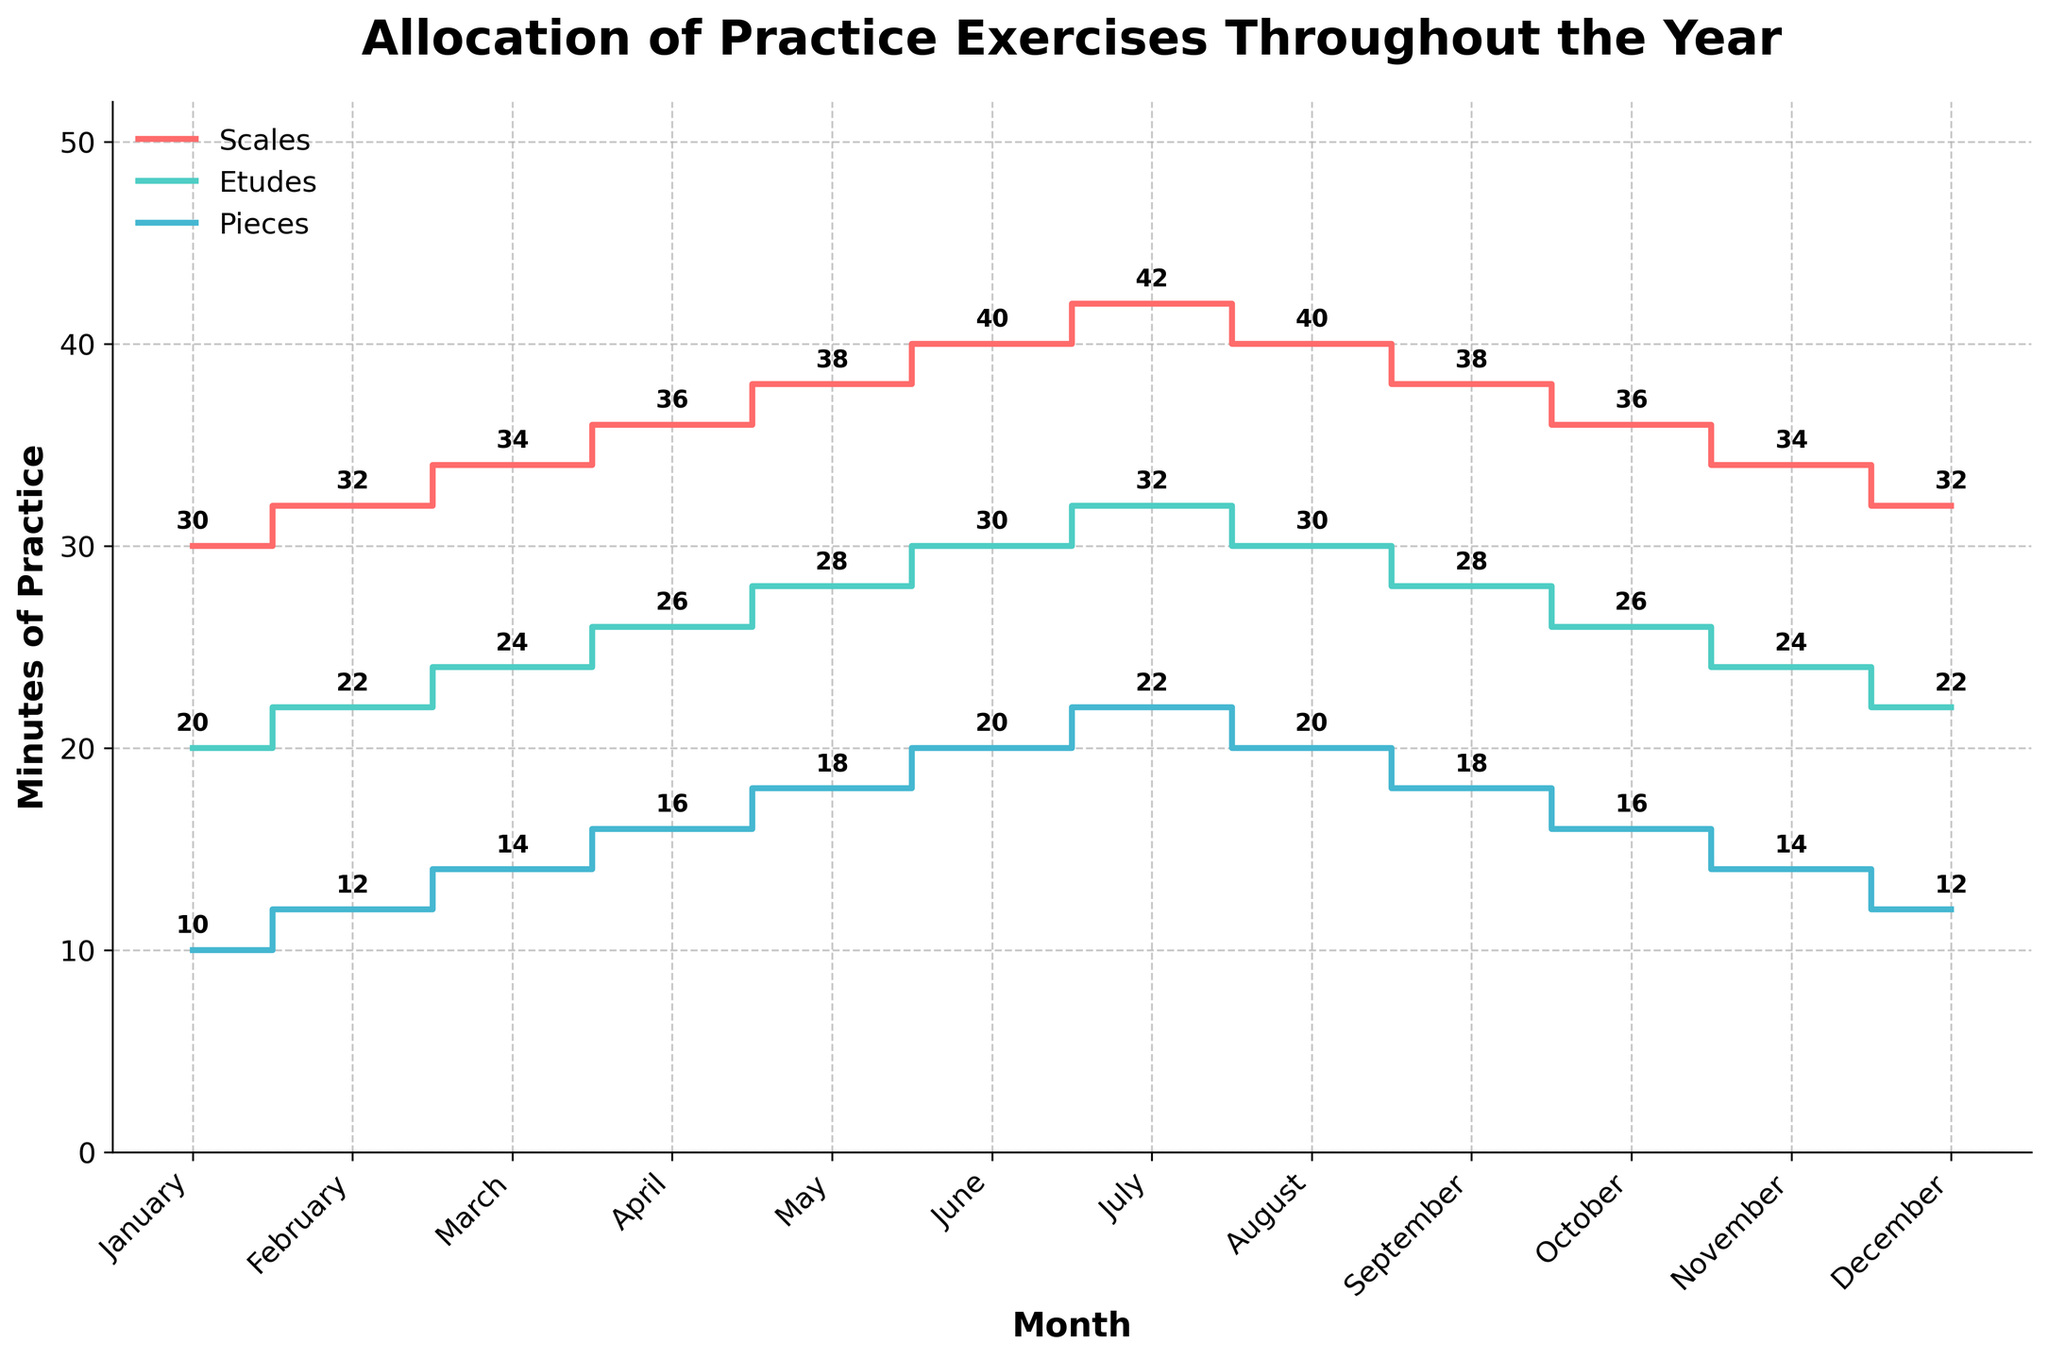What's the title of the plot? The title of the plot is mentioned at the top, in larger and bold font, which helps identify the main topic of the visualization.
Answer: Allocation of Practice Exercises Throughout the Year How many minutes were allocated to scales practice in June? Look at the point corresponding to June on the Scales stair plot line and read the annotation.
Answer: 40 In which month were the minutes allocated to etudes the highest? Identify the highest point of the Etudes stair plot line and see which month it corresponds to from the x-axis labels.
Answer: July What is the difference in minutes allocated to pieces between January and February? Compare the annotations for Pieces in January and February. Calculate the difference: February (12) - January (10).
Answer: 2 By how much did the minutes allocated to scales increase from March to April? Compare the annotations for Scales in March and April. Calculate the difference: April (36) - March (34).
Answer: 2 During which months do the minutes allocated to pieces remain constant? Examine the stair plot for Pieces and identify periods where the plot line is flat (no increase or decrease), particularly between two months.
Answer: June to August Which practice exercise shows the steepest increase in time allocation in the first half of the year? Compare the stair plot lines for Scales, Etudes, and Pieces from January to June. Determine which line has the highest gradient.
Answer: Scales What is the total increase in minutes allocated to etudes from January to July? Sum the monthly increases for Etudes from January to July. January (20) -> July (32): 32 - 20.
Answer: 12 How does the allocation of scales in January compare to December? Compare the annotations for Scales in January and December. Note the values are the same.
Answer: Same (32) Does the plot show any seasonal patterns in practice allocation? Observe the stair plot lines for all exercises and look for repeating patterns or changes that seem to recur every season (e.g., summer, autumn).
Answer: Yes, increase in the first half, decrease in the second half 